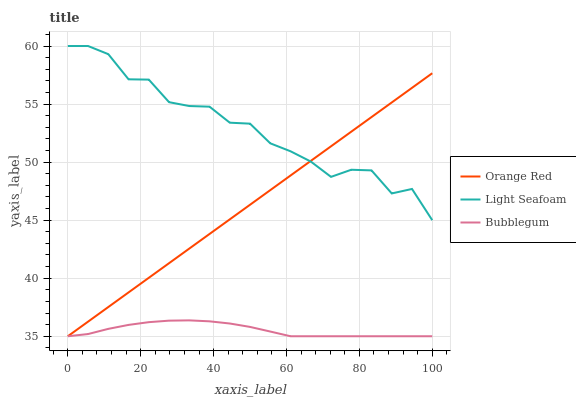Does Bubblegum have the minimum area under the curve?
Answer yes or no. Yes. Does Light Seafoam have the maximum area under the curve?
Answer yes or no. Yes. Does Orange Red have the minimum area under the curve?
Answer yes or no. No. Does Orange Red have the maximum area under the curve?
Answer yes or no. No. Is Orange Red the smoothest?
Answer yes or no. Yes. Is Light Seafoam the roughest?
Answer yes or no. Yes. Is Bubblegum the smoothest?
Answer yes or no. No. Is Bubblegum the roughest?
Answer yes or no. No. Does Light Seafoam have the highest value?
Answer yes or no. Yes. Does Orange Red have the highest value?
Answer yes or no. No. Is Bubblegum less than Light Seafoam?
Answer yes or no. Yes. Is Light Seafoam greater than Bubblegum?
Answer yes or no. Yes. Does Orange Red intersect Bubblegum?
Answer yes or no. Yes. Is Orange Red less than Bubblegum?
Answer yes or no. No. Is Orange Red greater than Bubblegum?
Answer yes or no. No. Does Bubblegum intersect Light Seafoam?
Answer yes or no. No. 